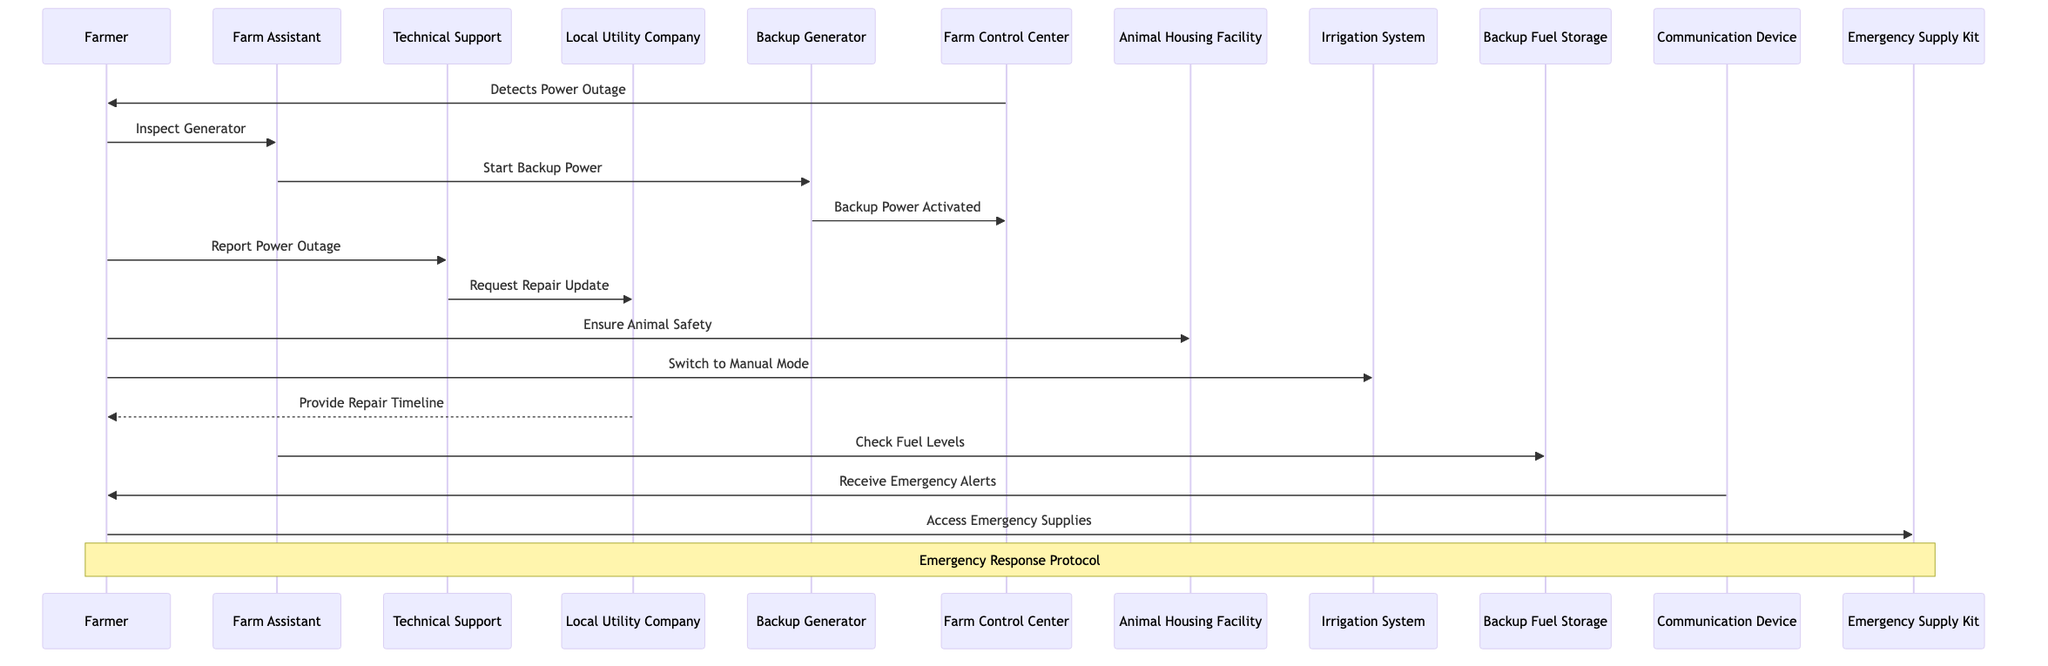what triggers the farmer's response in the diagram? The diagram indicates that the "Farm Control Center" detects a power outage, which signals to the "Farmer" to initiate the emergency response protocol. This is the first message that starts the sequence of actions taken by the farmer.
Answer: Detects Power Outage who is responsible for starting the backup generator? According to the diagram, the "Farm Assistant" is the one who receives the command from the "Farmer" to inspect the generator and is responsible for starting the backup power.
Answer: Farm Assistant how many participants are involved in the emergency response? The diagram identifies a total of ten participants who are actors in the emergency response, including the farmer, farm assistant, technical support, and others.
Answer: Ten what is the first action taken by the farmer after detecting the power outage? Following the detection of the power outage, the first action taken by the farmer is to command the farm assistant to inspect the generator. This shows the proactive approach of ensuring the backup system is ready.
Answer: Inspect Generator what does the backup generator report after being activated? After the backup generator is started by the farm assistant, it sends a signal back to the farm control center indicating that backup power has been activated. This signal confirms that the generator is working as intended.
Answer: Backup Power Activated which actor communicates with the local utility company? The "Technical Support" is the actor that communicates with the "Local Utility Company" by sending a command to request a repair update regarding the power outage situation on the farm.
Answer: Technical Support how does the farmer ensure the safety of the animals? The diagram shows that the farmer commands the animal housing facility to ensure animal safety, indicating that the farmer takes direct action to protect the livestock during the power outage event.
Answer: Ensure Animal Safety what action does the farmer take regarding the irrigation system? The farmer commands the irrigation system to switch to manual mode, a necessary step during a power outage to maintain the farm's irrigation needs without relying on automated systems.
Answer: Switch to Manual Mode who provides the farmer with a repair timeline? The local utility company provides the farmer with a response, delivering the repair timeline after receiving the request from technical support. This process informs the farmer about the expected time for power restoration.
Answer: Provide Repair Timeline 